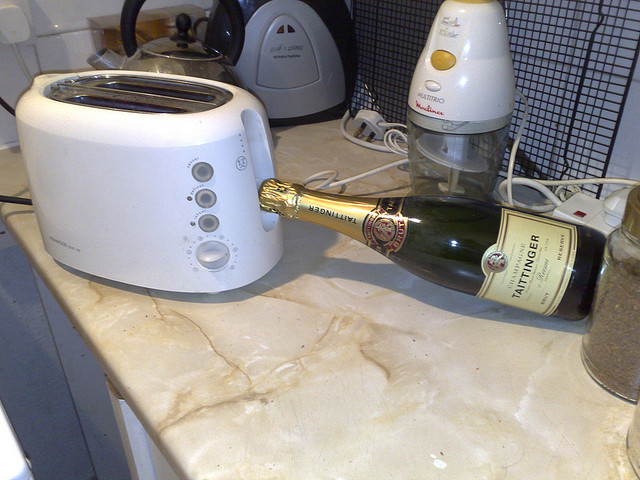<image>What type of event was this? I don't know what type of event this was. It could be a birthday, party, or a wine tasting event. What type of event was this? I'm not sure what type of event this was. It could be a birthday party, a wine tasting event, or just a general celebration. 